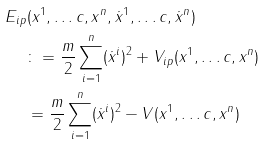<formula> <loc_0><loc_0><loc_500><loc_500>E _ { i p } & ( x ^ { 1 } , \dots c , x ^ { n } , \dot { x } ^ { 1 } , \dots c , \dot { x } ^ { n } ) \\ & \colon = \frac { m } { 2 } \sum _ { i = 1 } ^ { n } ( \dot { x } ^ { i } ) ^ { 2 } + V _ { i p } ( x ^ { 1 } , \dots c , x ^ { n } ) \\ & = \frac { m } { 2 } \sum _ { i = 1 } ^ { n } ( \dot { x } ^ { i } ) ^ { 2 } - V ( x ^ { 1 } , \dots c , x ^ { n } )</formula> 